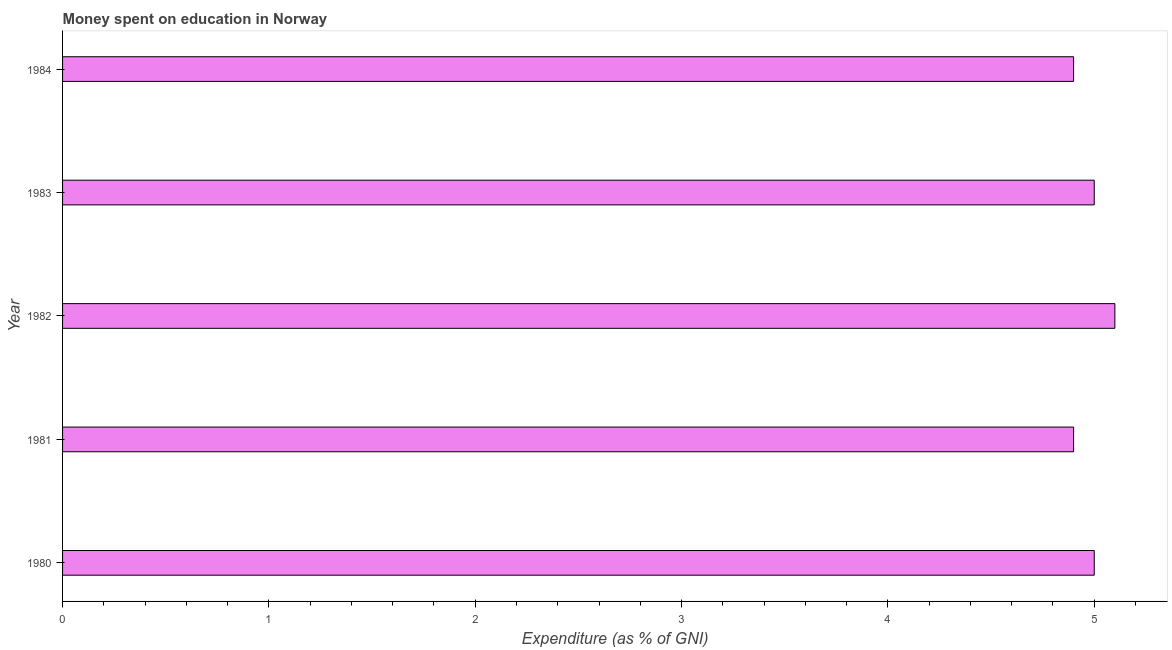What is the title of the graph?
Offer a very short reply. Money spent on education in Norway. What is the label or title of the X-axis?
Ensure brevity in your answer.  Expenditure (as % of GNI). What is the expenditure on education in 1980?
Offer a very short reply. 5. In which year was the expenditure on education maximum?
Keep it short and to the point. 1982. What is the sum of the expenditure on education?
Offer a terse response. 24.9. What is the average expenditure on education per year?
Offer a very short reply. 4.98. In how many years, is the expenditure on education greater than 1.4 %?
Offer a terse response. 5. What is the ratio of the expenditure on education in 1981 to that in 1983?
Give a very brief answer. 0.98. Is the difference between the expenditure on education in 1980 and 1982 greater than the difference between any two years?
Give a very brief answer. No. What is the difference between the highest and the second highest expenditure on education?
Make the answer very short. 0.1. What is the difference between the highest and the lowest expenditure on education?
Your answer should be compact. 0.2. In how many years, is the expenditure on education greater than the average expenditure on education taken over all years?
Your response must be concise. 3. How many bars are there?
Provide a short and direct response. 5. Are all the bars in the graph horizontal?
Provide a short and direct response. Yes. How many years are there in the graph?
Offer a terse response. 5. What is the difference between two consecutive major ticks on the X-axis?
Your response must be concise. 1. What is the difference between the Expenditure (as % of GNI) in 1980 and 1982?
Ensure brevity in your answer.  -0.1. What is the difference between the Expenditure (as % of GNI) in 1980 and 1984?
Your answer should be compact. 0.1. What is the ratio of the Expenditure (as % of GNI) in 1980 to that in 1981?
Keep it short and to the point. 1.02. What is the ratio of the Expenditure (as % of GNI) in 1980 to that in 1982?
Give a very brief answer. 0.98. What is the ratio of the Expenditure (as % of GNI) in 1982 to that in 1983?
Provide a short and direct response. 1.02. What is the ratio of the Expenditure (as % of GNI) in 1982 to that in 1984?
Offer a terse response. 1.04. 